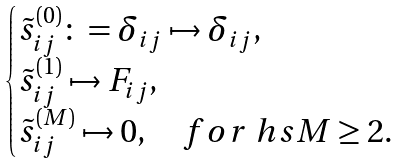Convert formula to latex. <formula><loc_0><loc_0><loc_500><loc_500>\begin{cases} \tilde { s } _ { i j } ^ { ( 0 ) } \colon = \delta _ { i j } \mapsto \delta _ { i j } , \\ \tilde { s } _ { i j } ^ { ( 1 ) } \mapsto F _ { i j } , \\ \tilde { s } _ { i j } ^ { ( M ) } \mapsto 0 , \quad f o r \ h s M \geq 2 . \\ \end{cases}</formula> 